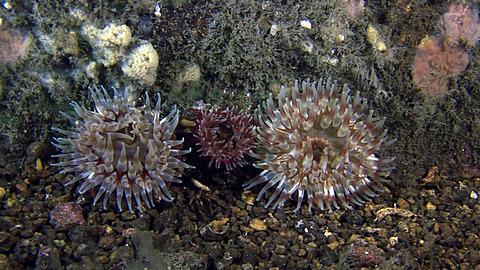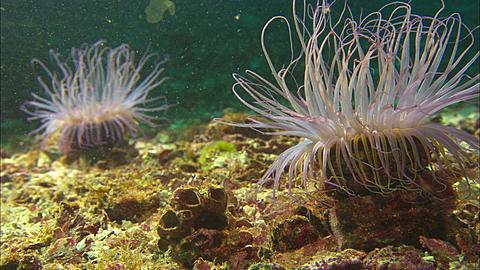The first image is the image on the left, the second image is the image on the right. Evaluate the accuracy of this statement regarding the images: "Each image shows one prominent flower-shaped anemone with tendrils radiating from a flatter center with a hole in it, but the anemone on the right is greenish-blue, and the one on the left is more yellowish.". Is it true? Answer yes or no. No. The first image is the image on the left, the second image is the image on the right. Considering the images on both sides, is "There is exactly one sea anemone in the right image." valid? Answer yes or no. No. 